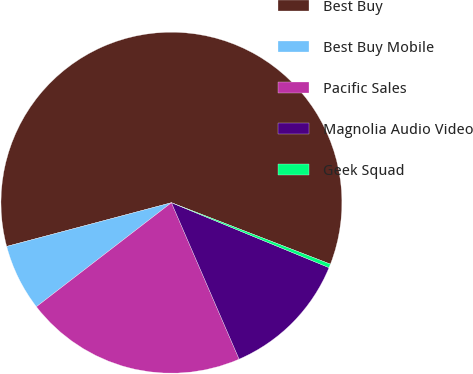Convert chart. <chart><loc_0><loc_0><loc_500><loc_500><pie_chart><fcel>Best Buy<fcel>Best Buy Mobile<fcel>Pacific Sales<fcel>Magnolia Audio Video<fcel>Geek Squad<nl><fcel>60.0%<fcel>6.32%<fcel>21.05%<fcel>12.28%<fcel>0.35%<nl></chart> 